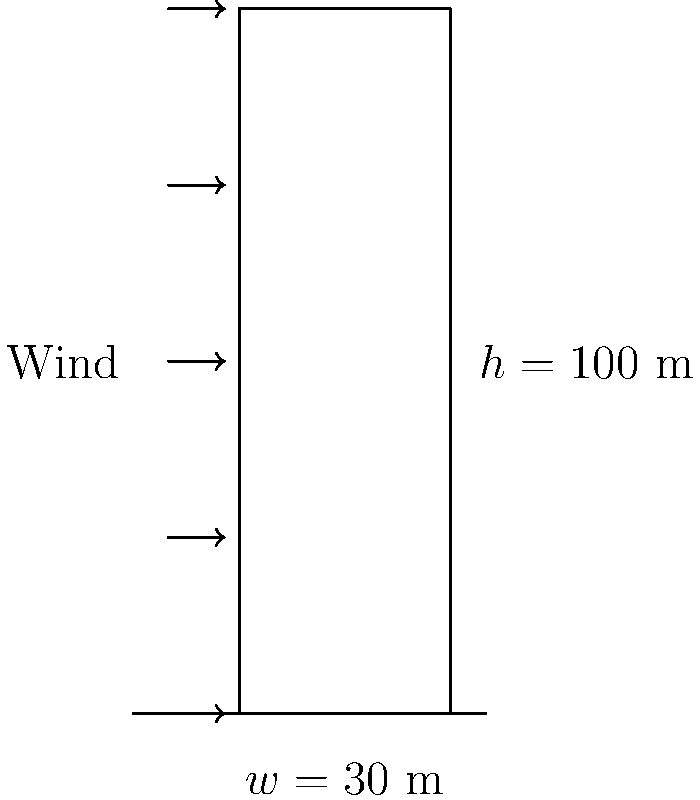As you hurriedly gather your spilled documents, you recall a project involving wind load calculations for a high-rise office building. The building is 100 meters tall and 30 meters wide. Using the simplified formula for wind pressure, $p = 0.5 \times \rho \times v^2 \times C_d$, where air density $\rho = 1.225$ kg/m³, wind velocity $v = 40$ m/s, and drag coefficient $C_d = 1.4$, what is the total wind force on the building's face? Let's approach this step-by-step:

1) First, we need to calculate the wind pressure using the given formula:
   $p = 0.5 \times \rho \times v^2 \times C_d$
   
2) Substituting the values:
   $p = 0.5 \times 1.225 \text{ kg/m³} \times (40 \text{ m/s})^2 \times 1.4$
   
3) Calculate:
   $p = 0.5 \times 1.225 \times 1600 \times 1.4 = 1372$ N/m²

4) Now, we need to find the area of the building's face:
   Area = height × width = 100 m × 30 m = 3000 m²

5) The total force is the pressure multiplied by the area:
   Force = pressure × area
   $F = 1372 \text{ N/m²} \times 3000 \text{ m²} = 4,116,000$ N

6) Convert to kilonewtons:
   $4,116,000 \text{ N} = 4,116 \text{ kN}$
Answer: 4,116 kN 